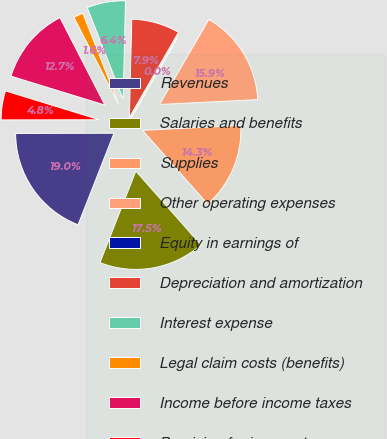Convert chart to OTSL. <chart><loc_0><loc_0><loc_500><loc_500><pie_chart><fcel>Revenues<fcel>Salaries and benefits<fcel>Supplies<fcel>Other operating expenses<fcel>Equity in earnings of<fcel>Depreciation and amortization<fcel>Interest expense<fcel>Legal claim costs (benefits)<fcel>Income before income taxes<fcel>Provision for income taxes<nl><fcel>19.03%<fcel>17.45%<fcel>14.28%<fcel>15.86%<fcel>0.02%<fcel>7.94%<fcel>6.35%<fcel>1.6%<fcel>12.69%<fcel>4.77%<nl></chart> 